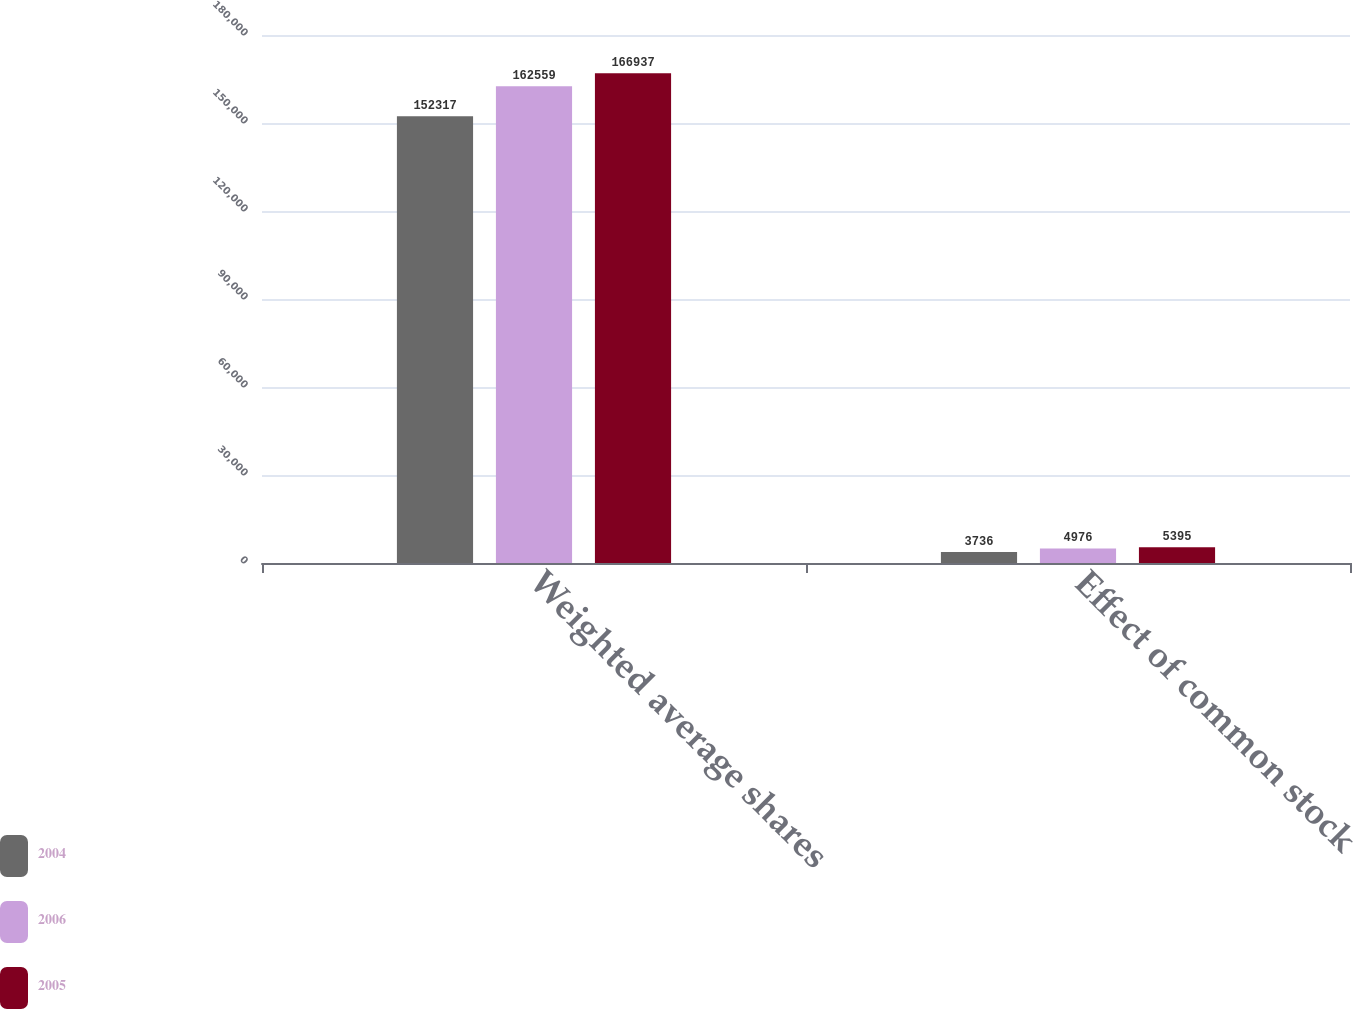Convert chart to OTSL. <chart><loc_0><loc_0><loc_500><loc_500><stacked_bar_chart><ecel><fcel>Weighted average shares<fcel>Effect of common stock<nl><fcel>2004<fcel>152317<fcel>3736<nl><fcel>2006<fcel>162559<fcel>4976<nl><fcel>2005<fcel>166937<fcel>5395<nl></chart> 